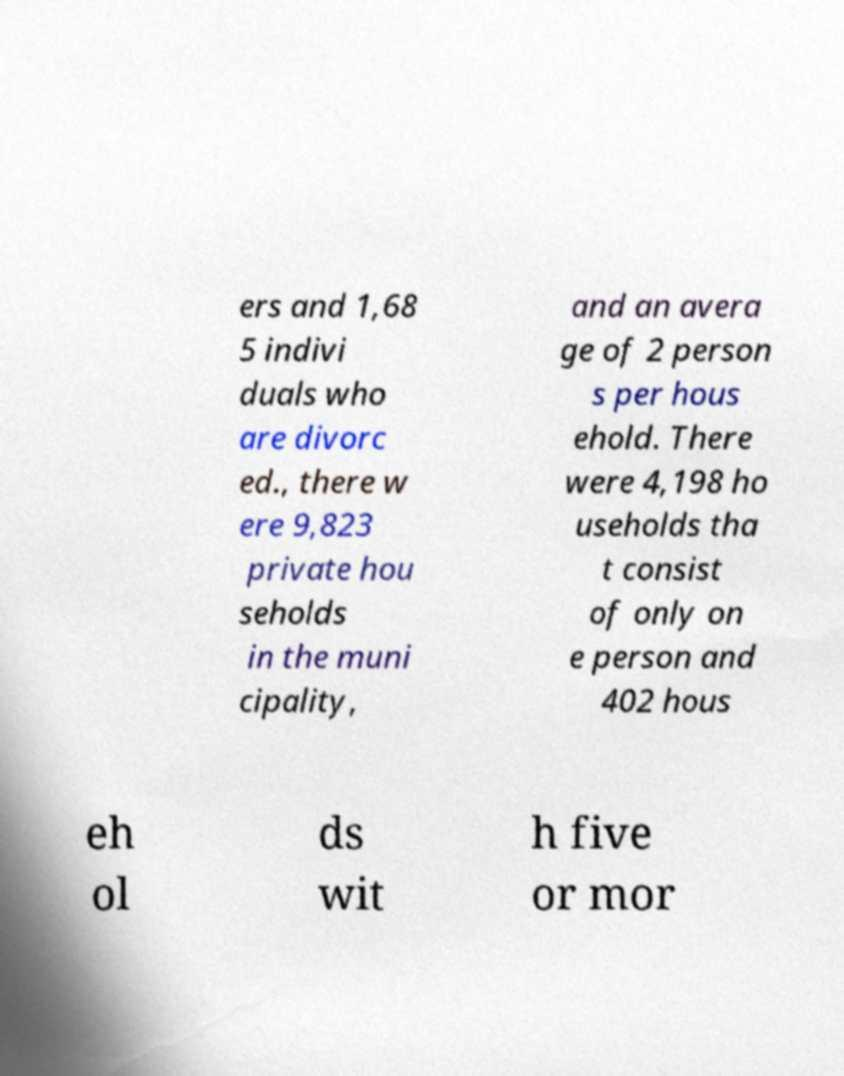Can you read and provide the text displayed in the image?This photo seems to have some interesting text. Can you extract and type it out for me? ers and 1,68 5 indivi duals who are divorc ed., there w ere 9,823 private hou seholds in the muni cipality, and an avera ge of 2 person s per hous ehold. There were 4,198 ho useholds tha t consist of only on e person and 402 hous eh ol ds wit h five or mor 